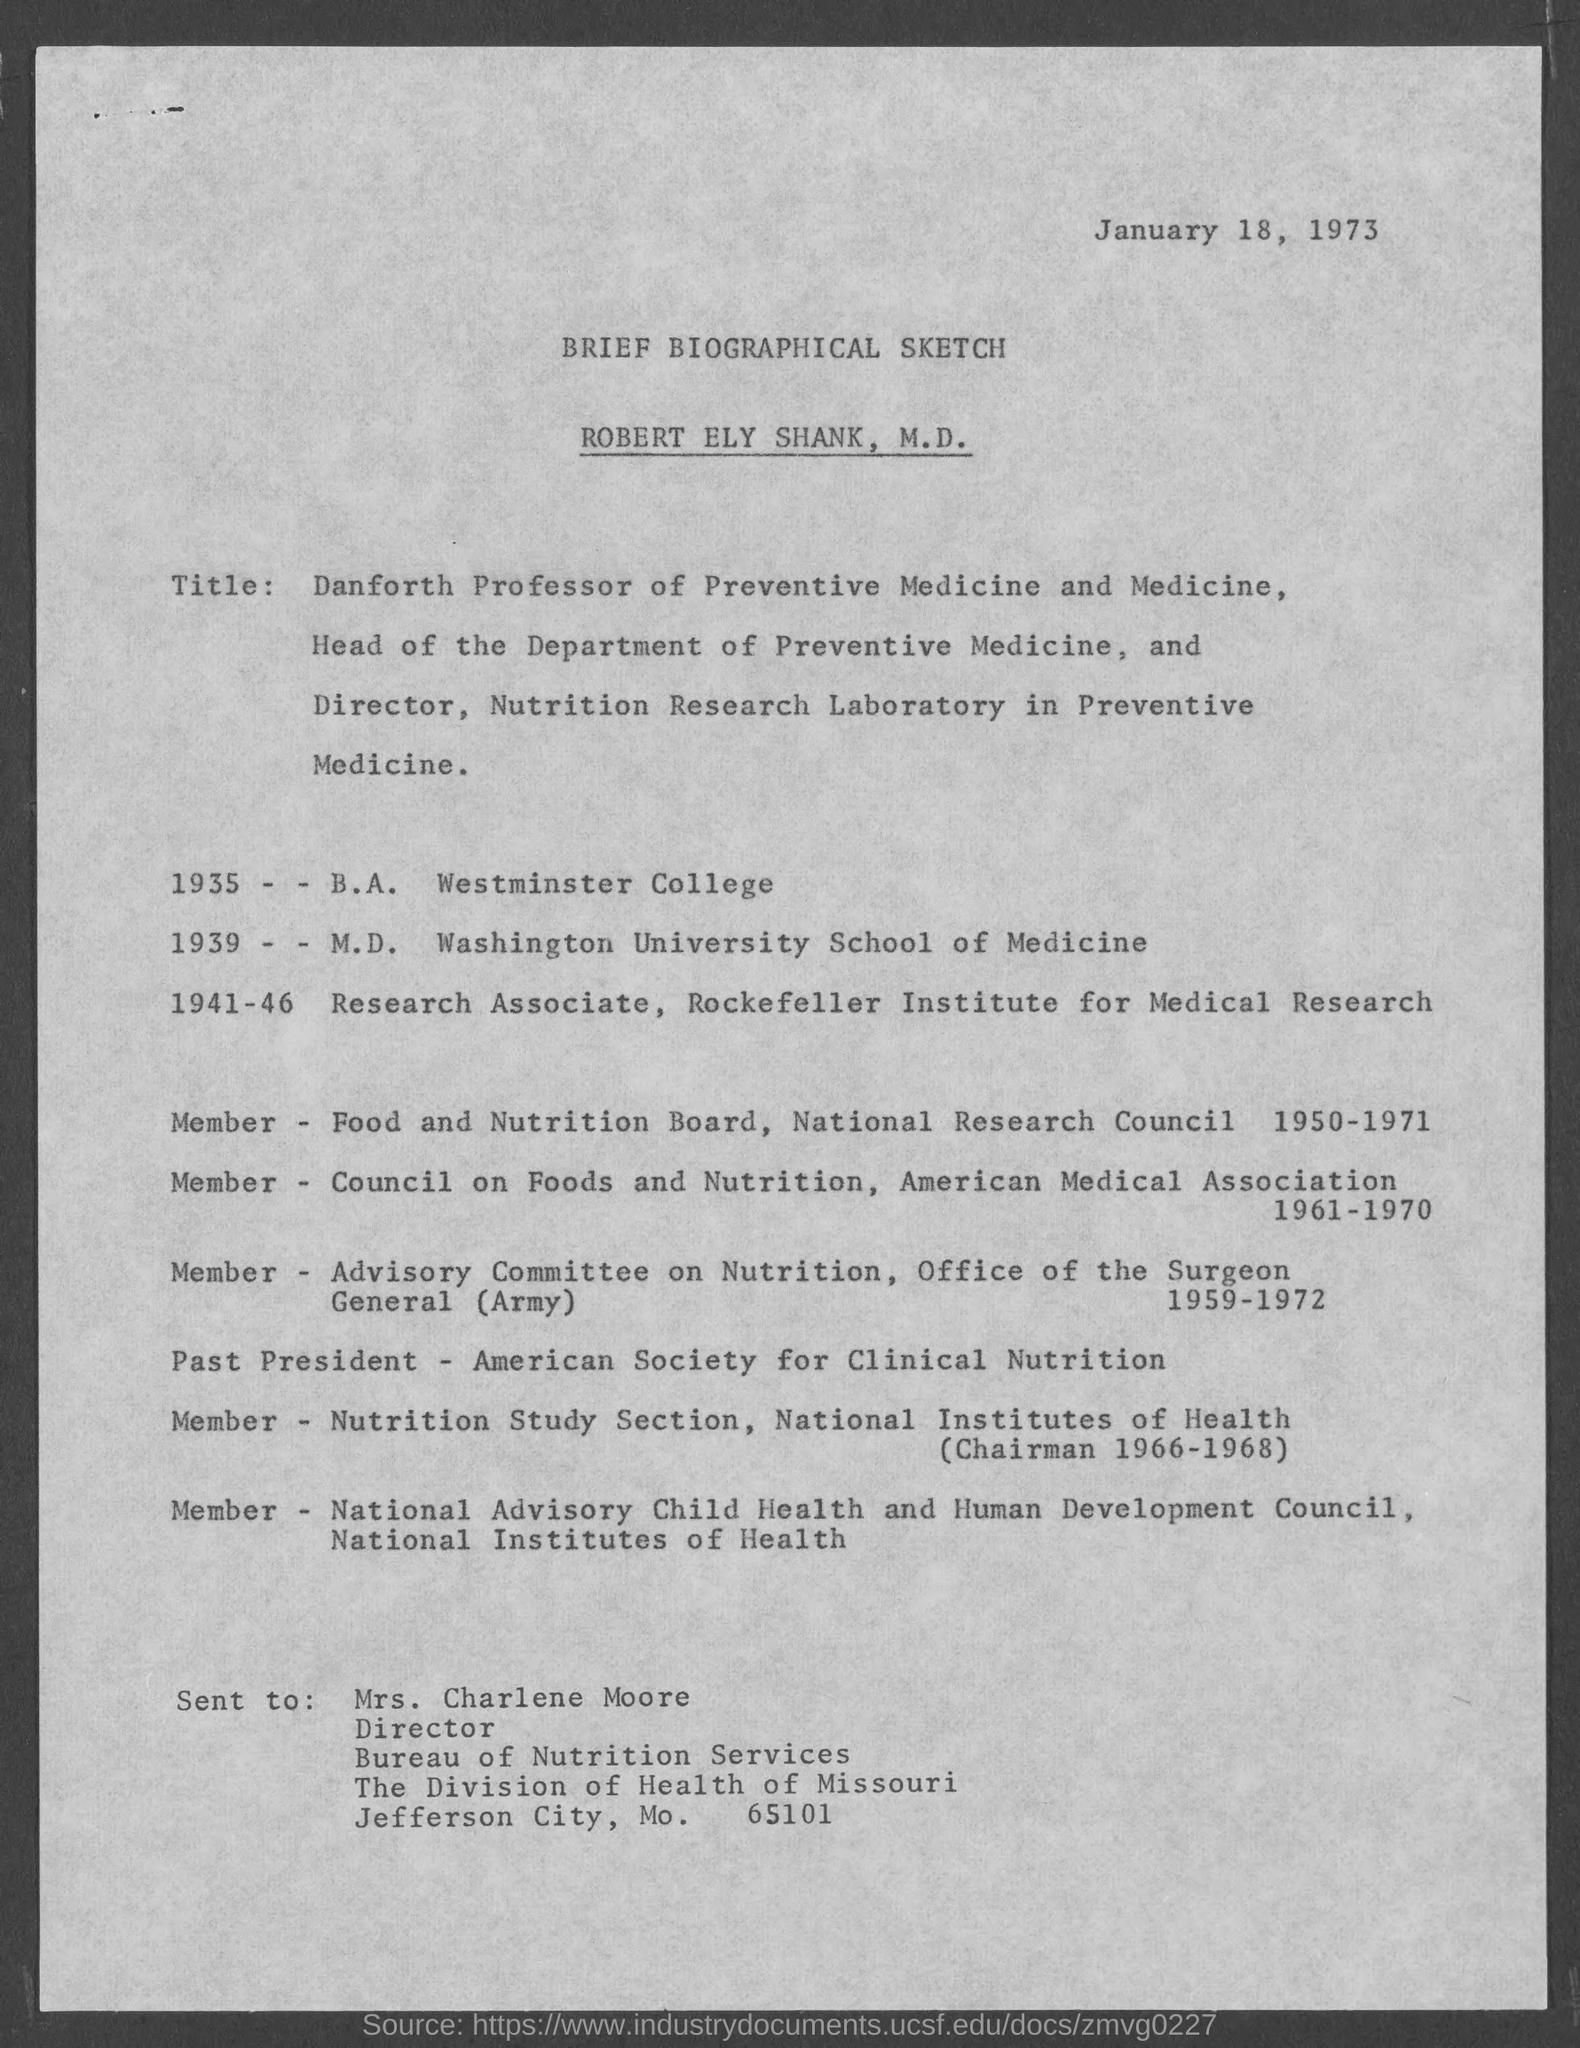What is the date mentioned in the given page ?
Give a very brief answer. January 18, 1973. What is the name of the sketch mentioned in the given page ?
Give a very brief answer. Brief biographical sketch. To whom this letter was sent ?
Your answer should be very brief. Mrs. charlene moore. What is the designation of mrs. charlene moore?
Ensure brevity in your answer.  Director. 